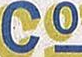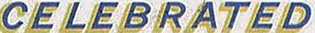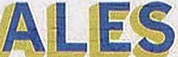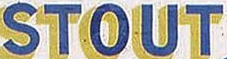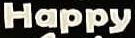What words are shown in these images in order, separated by a semicolon? Co; CELEBRATED; ALES; STOUT; Happy 